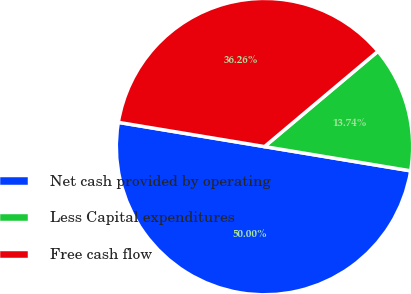<chart> <loc_0><loc_0><loc_500><loc_500><pie_chart><fcel>Net cash provided by operating<fcel>Less Capital expenditures<fcel>Free cash flow<nl><fcel>50.0%<fcel>13.74%<fcel>36.26%<nl></chart> 